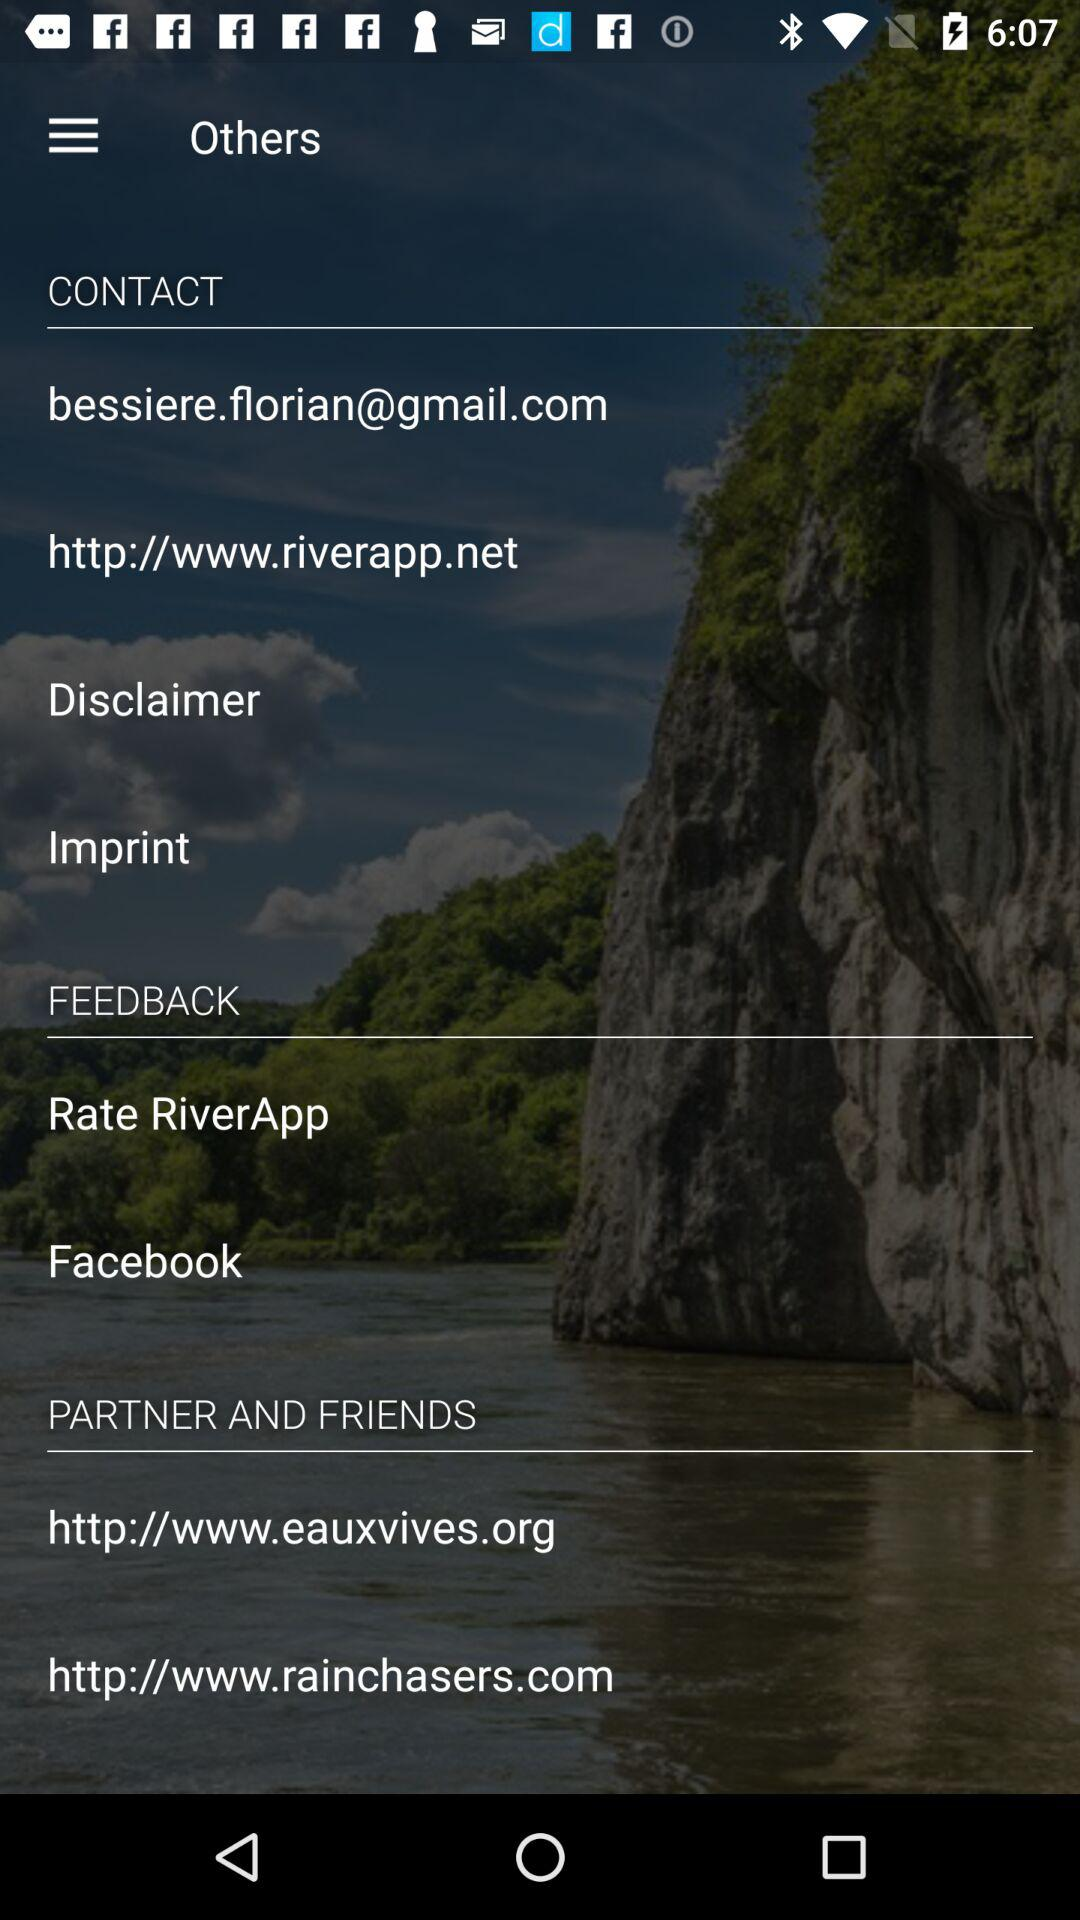What is the contact email ID? The email ID is bessiere.florian@gmail.com. 